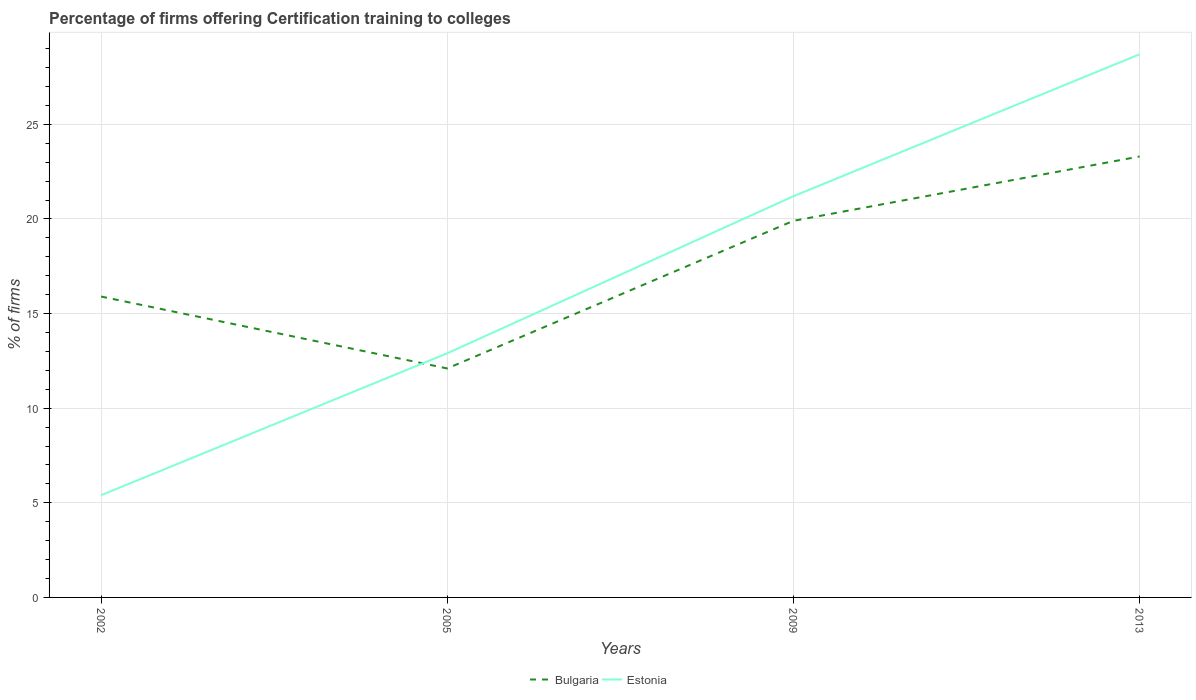How many different coloured lines are there?
Keep it short and to the point. 2. Does the line corresponding to Bulgaria intersect with the line corresponding to Estonia?
Provide a succinct answer. Yes. Is the number of lines equal to the number of legend labels?
Your response must be concise. Yes. Across all years, what is the maximum percentage of firms offering certification training to colleges in Estonia?
Make the answer very short. 5.4. What is the total percentage of firms offering certification training to colleges in Bulgaria in the graph?
Offer a very short reply. -4. What is the difference between the highest and the second highest percentage of firms offering certification training to colleges in Estonia?
Your answer should be compact. 23.3. What is the difference between the highest and the lowest percentage of firms offering certification training to colleges in Estonia?
Offer a very short reply. 2. Is the percentage of firms offering certification training to colleges in Estonia strictly greater than the percentage of firms offering certification training to colleges in Bulgaria over the years?
Provide a short and direct response. No. How many lines are there?
Offer a terse response. 2. How many years are there in the graph?
Offer a terse response. 4. What is the difference between two consecutive major ticks on the Y-axis?
Make the answer very short. 5. Does the graph contain grids?
Provide a succinct answer. Yes. Where does the legend appear in the graph?
Provide a short and direct response. Bottom center. How many legend labels are there?
Your response must be concise. 2. How are the legend labels stacked?
Provide a short and direct response. Horizontal. What is the title of the graph?
Provide a succinct answer. Percentage of firms offering Certification training to colleges. Does "South Sudan" appear as one of the legend labels in the graph?
Your answer should be very brief. No. What is the label or title of the Y-axis?
Your answer should be very brief. % of firms. What is the % of firms of Estonia in 2002?
Provide a succinct answer. 5.4. What is the % of firms in Bulgaria in 2009?
Make the answer very short. 19.9. What is the % of firms in Estonia in 2009?
Offer a terse response. 21.2. What is the % of firms in Bulgaria in 2013?
Ensure brevity in your answer.  23.3. What is the % of firms in Estonia in 2013?
Your answer should be compact. 28.7. Across all years, what is the maximum % of firms of Bulgaria?
Your answer should be compact. 23.3. Across all years, what is the maximum % of firms of Estonia?
Keep it short and to the point. 28.7. Across all years, what is the minimum % of firms of Bulgaria?
Your answer should be very brief. 12.1. What is the total % of firms in Bulgaria in the graph?
Give a very brief answer. 71.2. What is the total % of firms of Estonia in the graph?
Your response must be concise. 68.2. What is the difference between the % of firms of Bulgaria in 2002 and that in 2005?
Provide a succinct answer. 3.8. What is the difference between the % of firms in Estonia in 2002 and that in 2005?
Provide a short and direct response. -7.5. What is the difference between the % of firms of Estonia in 2002 and that in 2009?
Provide a succinct answer. -15.8. What is the difference between the % of firms in Bulgaria in 2002 and that in 2013?
Offer a very short reply. -7.4. What is the difference between the % of firms of Estonia in 2002 and that in 2013?
Your response must be concise. -23.3. What is the difference between the % of firms in Bulgaria in 2005 and that in 2009?
Make the answer very short. -7.8. What is the difference between the % of firms of Estonia in 2005 and that in 2009?
Your answer should be compact. -8.3. What is the difference between the % of firms in Bulgaria in 2005 and that in 2013?
Offer a very short reply. -11.2. What is the difference between the % of firms in Estonia in 2005 and that in 2013?
Your response must be concise. -15.8. What is the difference between the % of firms of Bulgaria in 2009 and that in 2013?
Offer a very short reply. -3.4. What is the difference between the % of firms of Estonia in 2009 and that in 2013?
Provide a short and direct response. -7.5. What is the difference between the % of firms of Bulgaria in 2002 and the % of firms of Estonia in 2005?
Give a very brief answer. 3. What is the difference between the % of firms of Bulgaria in 2005 and the % of firms of Estonia in 2009?
Ensure brevity in your answer.  -9.1. What is the difference between the % of firms in Bulgaria in 2005 and the % of firms in Estonia in 2013?
Your answer should be very brief. -16.6. What is the average % of firms in Estonia per year?
Keep it short and to the point. 17.05. In the year 2002, what is the difference between the % of firms of Bulgaria and % of firms of Estonia?
Make the answer very short. 10.5. In the year 2009, what is the difference between the % of firms in Bulgaria and % of firms in Estonia?
Make the answer very short. -1.3. What is the ratio of the % of firms in Bulgaria in 2002 to that in 2005?
Offer a terse response. 1.31. What is the ratio of the % of firms in Estonia in 2002 to that in 2005?
Ensure brevity in your answer.  0.42. What is the ratio of the % of firms of Bulgaria in 2002 to that in 2009?
Your answer should be compact. 0.8. What is the ratio of the % of firms of Estonia in 2002 to that in 2009?
Make the answer very short. 0.25. What is the ratio of the % of firms in Bulgaria in 2002 to that in 2013?
Offer a very short reply. 0.68. What is the ratio of the % of firms in Estonia in 2002 to that in 2013?
Give a very brief answer. 0.19. What is the ratio of the % of firms in Bulgaria in 2005 to that in 2009?
Ensure brevity in your answer.  0.61. What is the ratio of the % of firms of Estonia in 2005 to that in 2009?
Offer a terse response. 0.61. What is the ratio of the % of firms of Bulgaria in 2005 to that in 2013?
Your response must be concise. 0.52. What is the ratio of the % of firms of Estonia in 2005 to that in 2013?
Provide a succinct answer. 0.45. What is the ratio of the % of firms of Bulgaria in 2009 to that in 2013?
Provide a short and direct response. 0.85. What is the ratio of the % of firms in Estonia in 2009 to that in 2013?
Keep it short and to the point. 0.74. What is the difference between the highest and the second highest % of firms of Bulgaria?
Your answer should be compact. 3.4. What is the difference between the highest and the lowest % of firms in Bulgaria?
Keep it short and to the point. 11.2. What is the difference between the highest and the lowest % of firms in Estonia?
Make the answer very short. 23.3. 